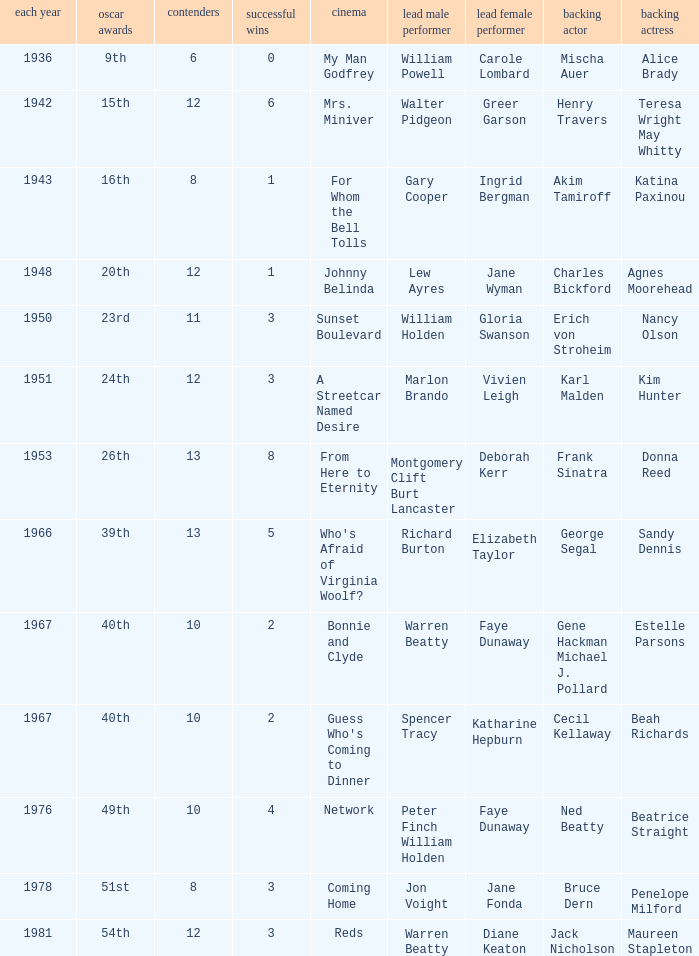Which film had Charles Bickford as supporting actor? Johnny Belinda. 